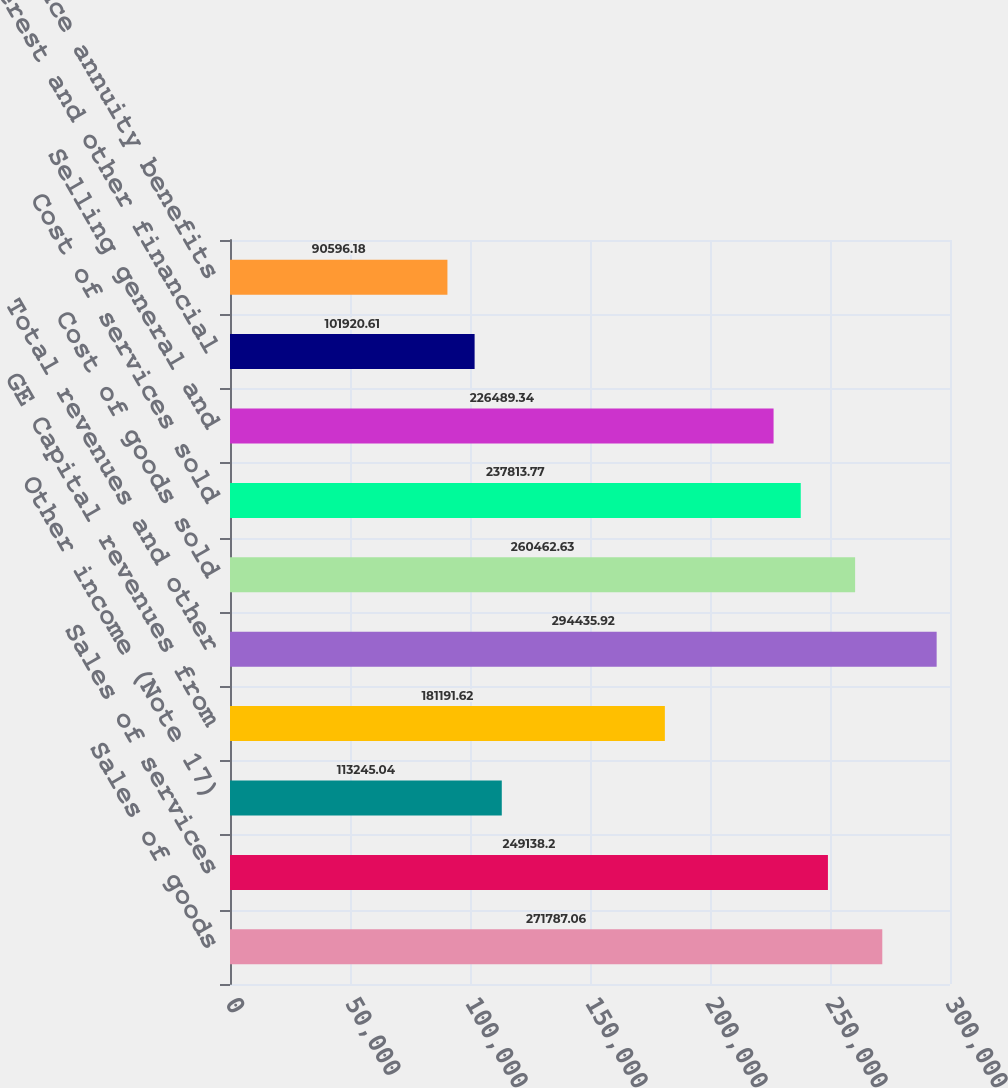<chart> <loc_0><loc_0><loc_500><loc_500><bar_chart><fcel>Sales of goods<fcel>Sales of services<fcel>Other income (Note 17)<fcel>GE Capital revenues from<fcel>Total revenues and other<fcel>Cost of goods sold<fcel>Cost of services sold<fcel>Selling general and<fcel>Interest and other financial<fcel>insurance annuity benefits<nl><fcel>271787<fcel>249138<fcel>113245<fcel>181192<fcel>294436<fcel>260463<fcel>237814<fcel>226489<fcel>101921<fcel>90596.2<nl></chart> 